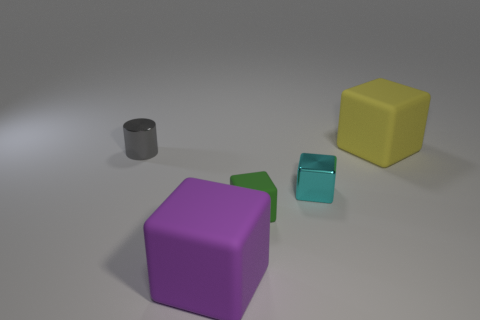There is another tiny object that is made of the same material as the purple thing; what is its shape?
Offer a very short reply. Cube. There is a green object; is it the same shape as the tiny metal object on the right side of the cylinder?
Give a very brief answer. Yes. The large block that is to the left of the big matte object behind the small shiny cylinder is made of what material?
Offer a very short reply. Rubber. Are there the same number of tiny rubber things behind the small cyan thing and small metal blocks?
Your response must be concise. No. How many objects are both on the right side of the gray metal cylinder and behind the cyan thing?
Keep it short and to the point. 1. What number of other things are the same shape as the gray thing?
Ensure brevity in your answer.  0. Are there more rubber objects in front of the cyan cube than big yellow rubber things?
Give a very brief answer. Yes. What color is the small thing that is to the left of the green matte thing?
Keep it short and to the point. Gray. What number of rubber objects are either large objects or yellow things?
Your answer should be very brief. 2. There is a large cube that is to the left of the big object to the right of the large purple matte block; are there any large purple matte objects that are behind it?
Your answer should be compact. No. 